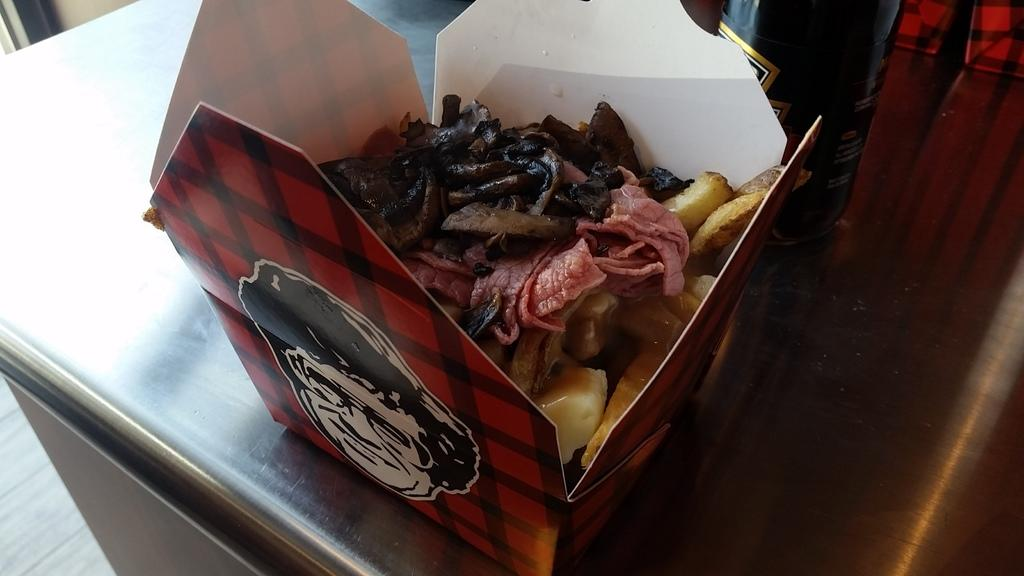What type of surface is present in the image? There is a metal surface in the image. What is placed on the metal surface? There is a box on the metal surface. What can be found inside the box? The box contains food items. Can you identify a specific type of food item in the box? Yes, there is a bottle among the food items. What else can be seen in the image besides the metal surface and the box? The floor is visible in the image. What type of button can be seen in the image? There is no button present in the image. 